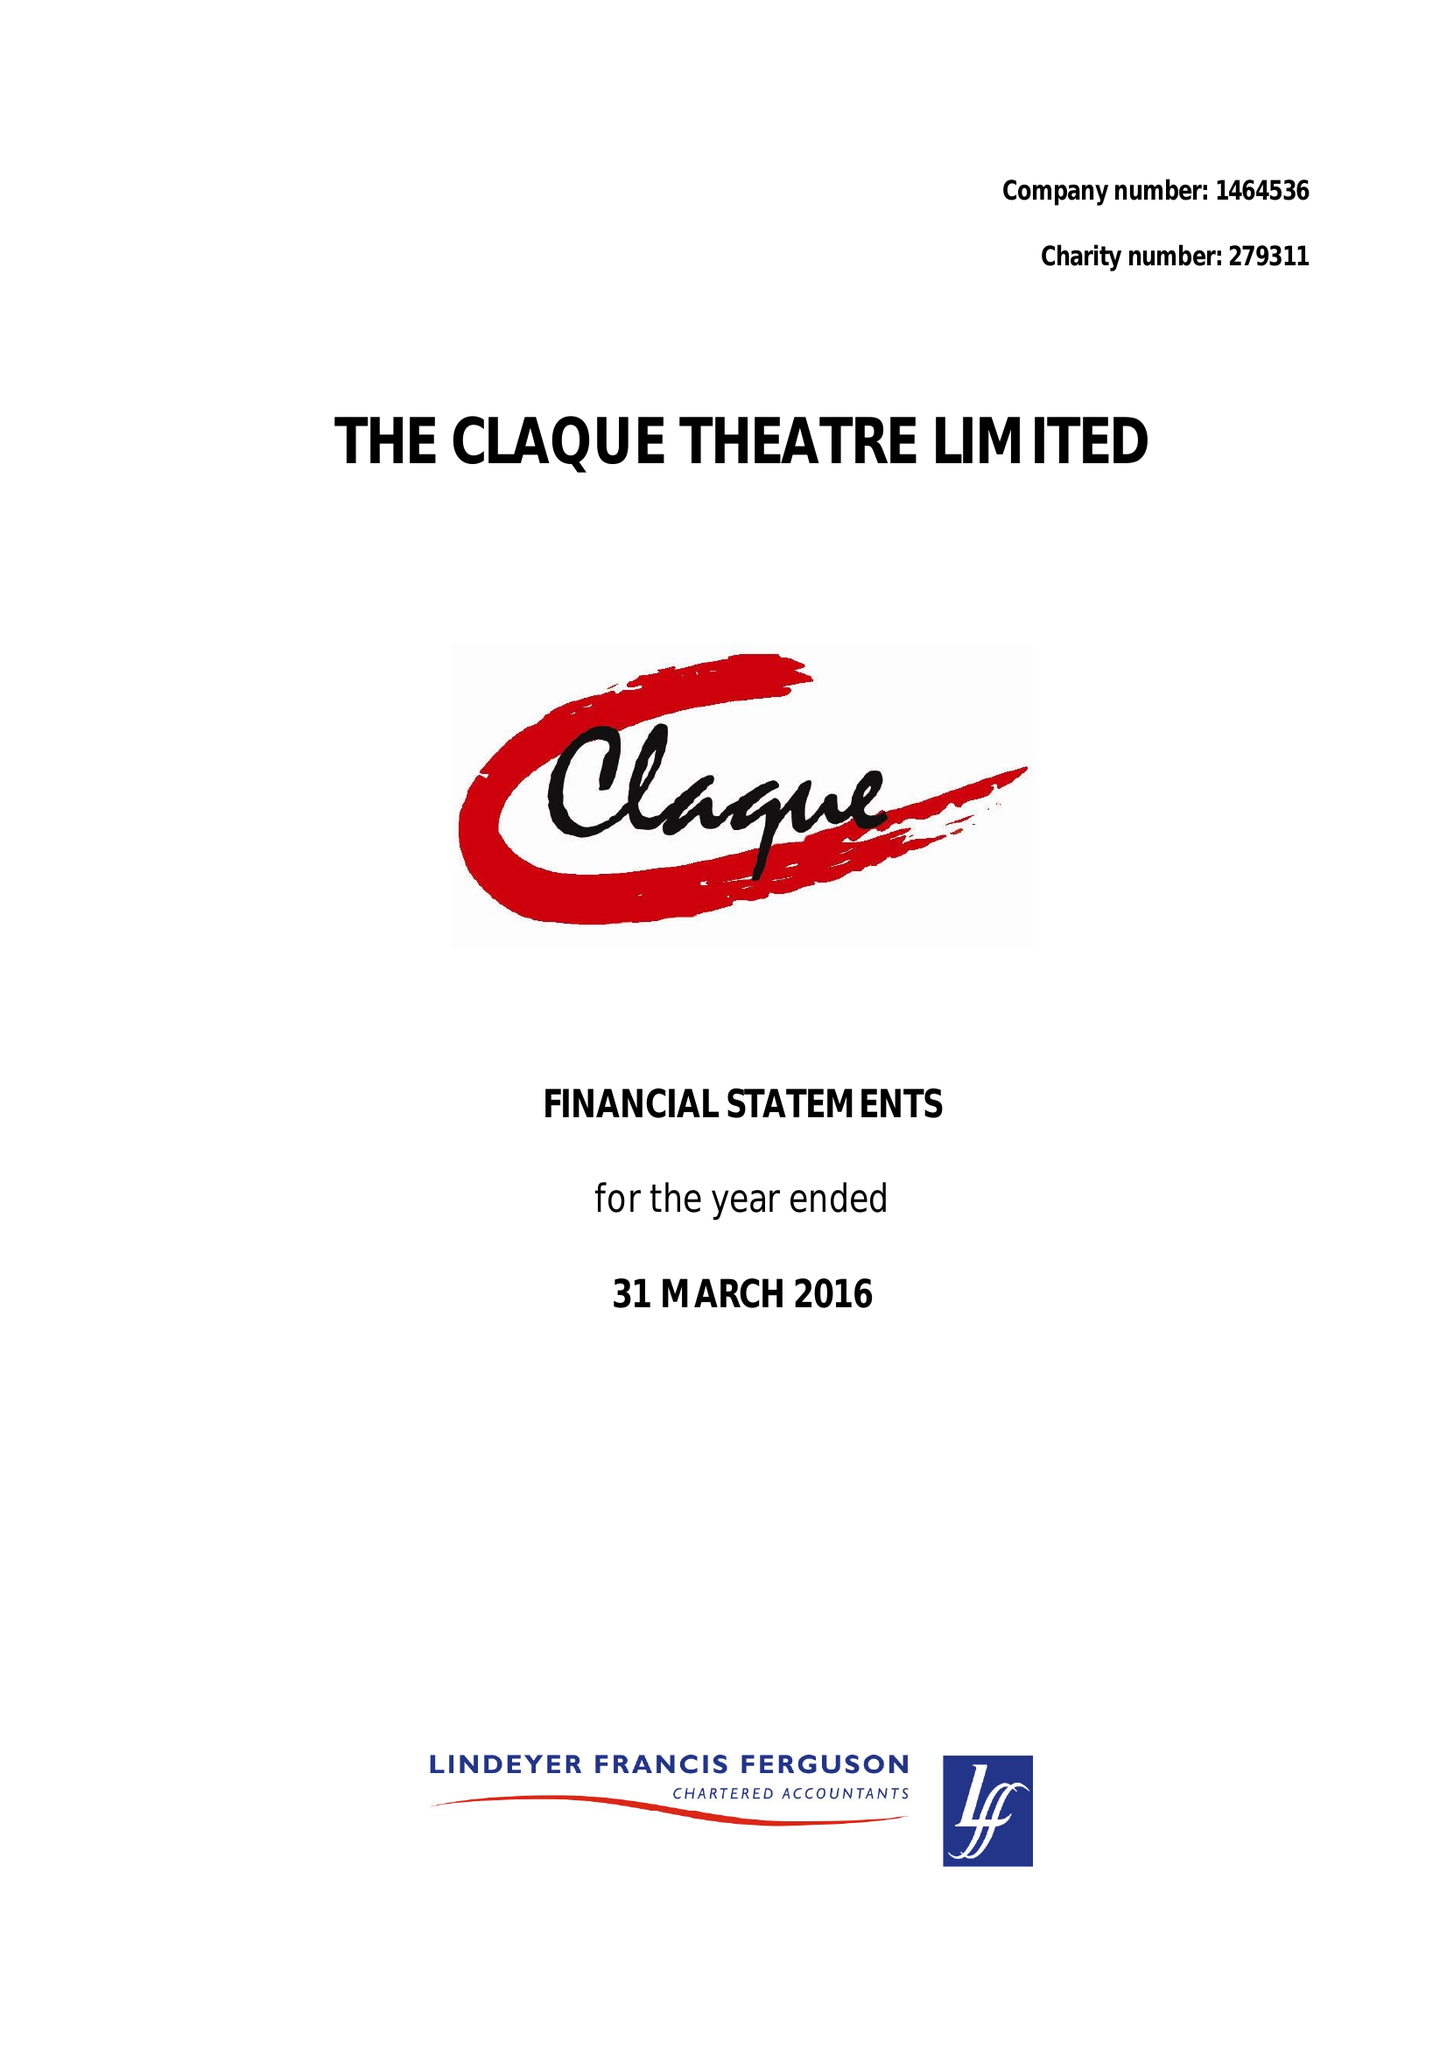What is the value for the address__postcode?
Answer the question using a single word or phrase. TN4 8NU 